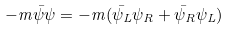Convert formula to latex. <formula><loc_0><loc_0><loc_500><loc_500>- m { \bar { \psi } } \psi = - m ( { \bar { \psi } } _ { L } \psi _ { R } + { \bar { \psi } } _ { R } \psi _ { L } )</formula> 